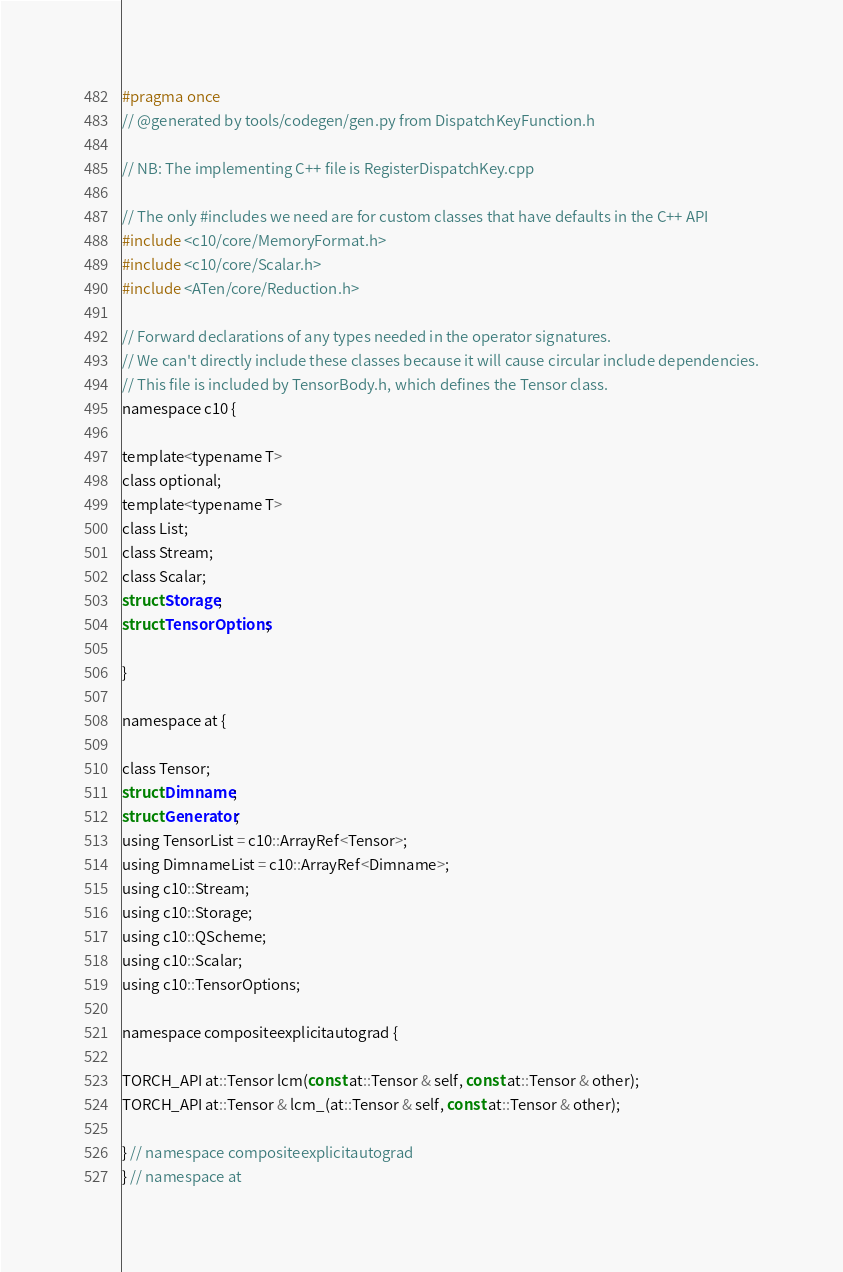<code> <loc_0><loc_0><loc_500><loc_500><_C_>#pragma once
// @generated by tools/codegen/gen.py from DispatchKeyFunction.h

// NB: The implementing C++ file is RegisterDispatchKey.cpp

// The only #includes we need are for custom classes that have defaults in the C++ API
#include <c10/core/MemoryFormat.h>
#include <c10/core/Scalar.h>
#include <ATen/core/Reduction.h>

// Forward declarations of any types needed in the operator signatures.
// We can't directly include these classes because it will cause circular include dependencies.
// This file is included by TensorBody.h, which defines the Tensor class.
namespace c10 {

template<typename T>
class optional;
template<typename T>
class List;
class Stream;
class Scalar;
struct Storage;
struct TensorOptions;

}

namespace at {

class Tensor;
struct Dimname;
struct Generator;
using TensorList = c10::ArrayRef<Tensor>;
using DimnameList = c10::ArrayRef<Dimname>;
using c10::Stream;
using c10::Storage;
using c10::QScheme;
using c10::Scalar;
using c10::TensorOptions;

namespace compositeexplicitautograd {

TORCH_API at::Tensor lcm(const at::Tensor & self, const at::Tensor & other);
TORCH_API at::Tensor & lcm_(at::Tensor & self, const at::Tensor & other);

} // namespace compositeexplicitautograd
} // namespace at
</code> 